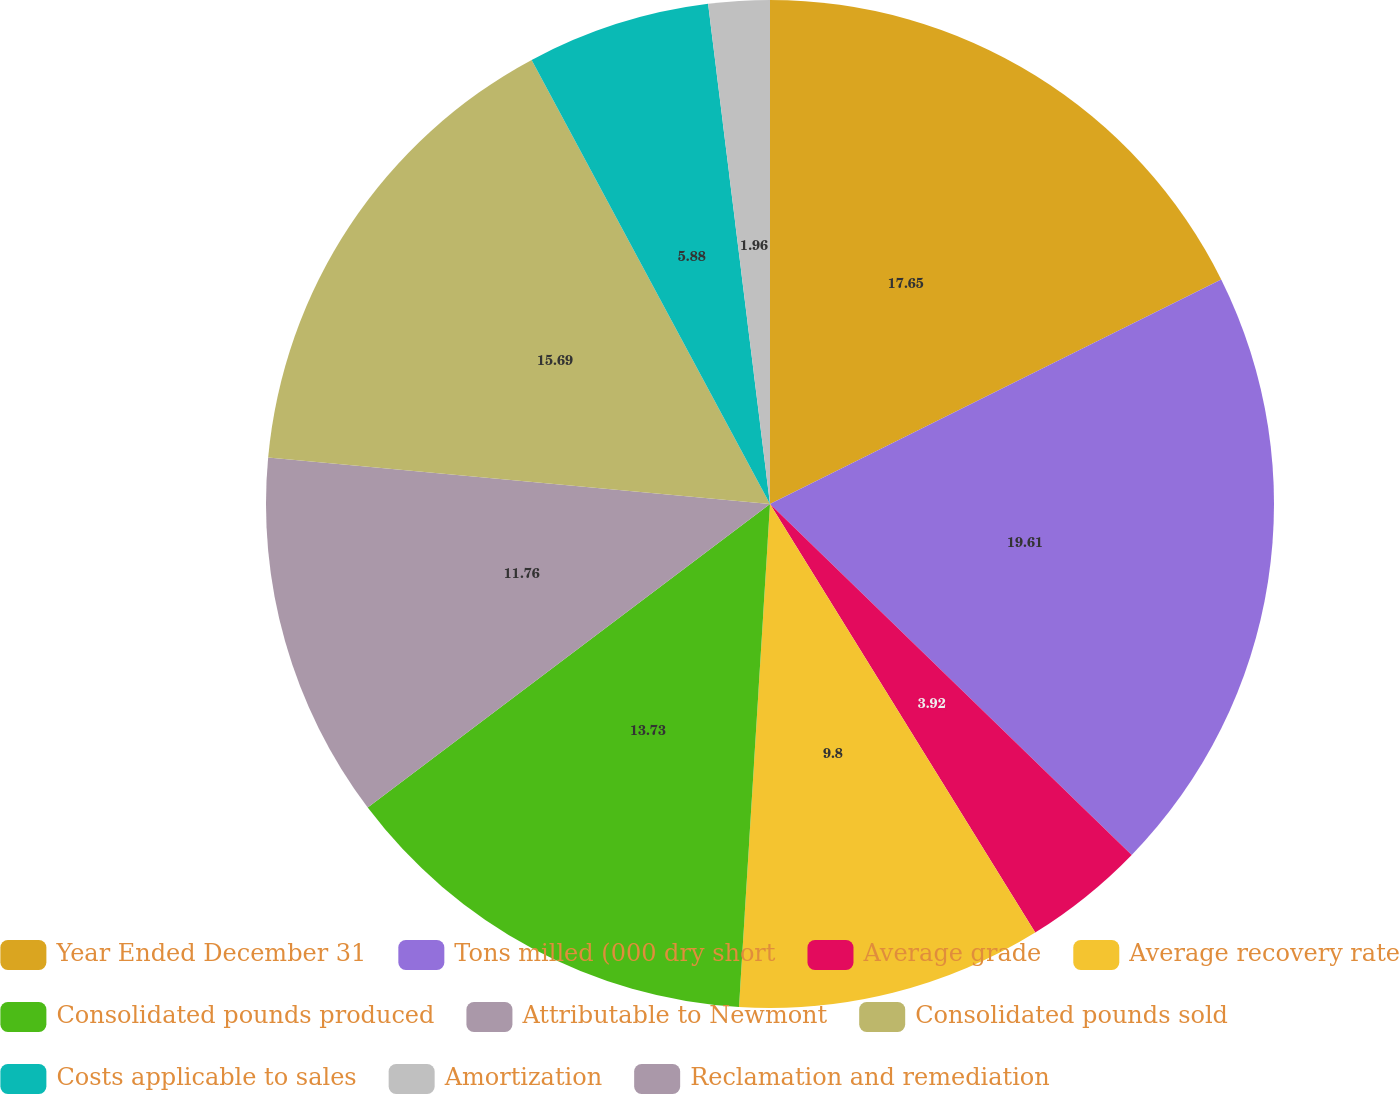<chart> <loc_0><loc_0><loc_500><loc_500><pie_chart><fcel>Year Ended December 31<fcel>Tons milled (000 dry short<fcel>Average grade<fcel>Average recovery rate<fcel>Consolidated pounds produced<fcel>Attributable to Newmont<fcel>Consolidated pounds sold<fcel>Costs applicable to sales<fcel>Amortization<fcel>Reclamation and remediation<nl><fcel>17.65%<fcel>19.61%<fcel>3.92%<fcel>9.8%<fcel>13.73%<fcel>11.76%<fcel>15.69%<fcel>5.88%<fcel>1.96%<fcel>0.0%<nl></chart> 